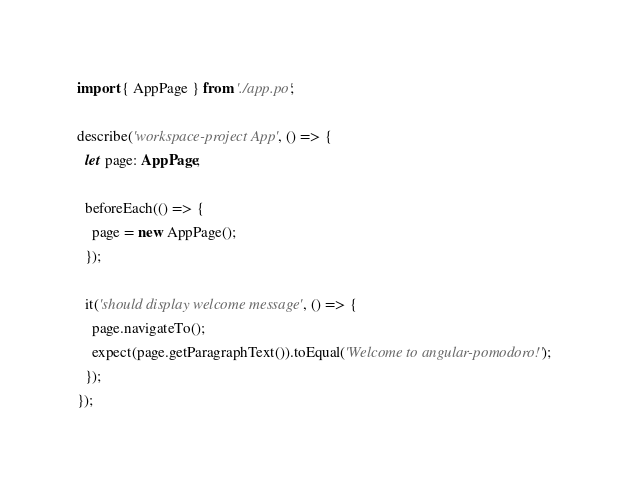<code> <loc_0><loc_0><loc_500><loc_500><_TypeScript_>import { AppPage } from './app.po';

describe('workspace-project App', () => {
  let page: AppPage;

  beforeEach(() => {
    page = new AppPage();
  });

  it('should display welcome message', () => {
    page.navigateTo();
    expect(page.getParagraphText()).toEqual('Welcome to angular-pomodoro!');
  });
});
</code> 